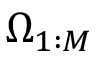Convert formula to latex. <formula><loc_0><loc_0><loc_500><loc_500>\Omega _ { 1 \colon M }</formula> 